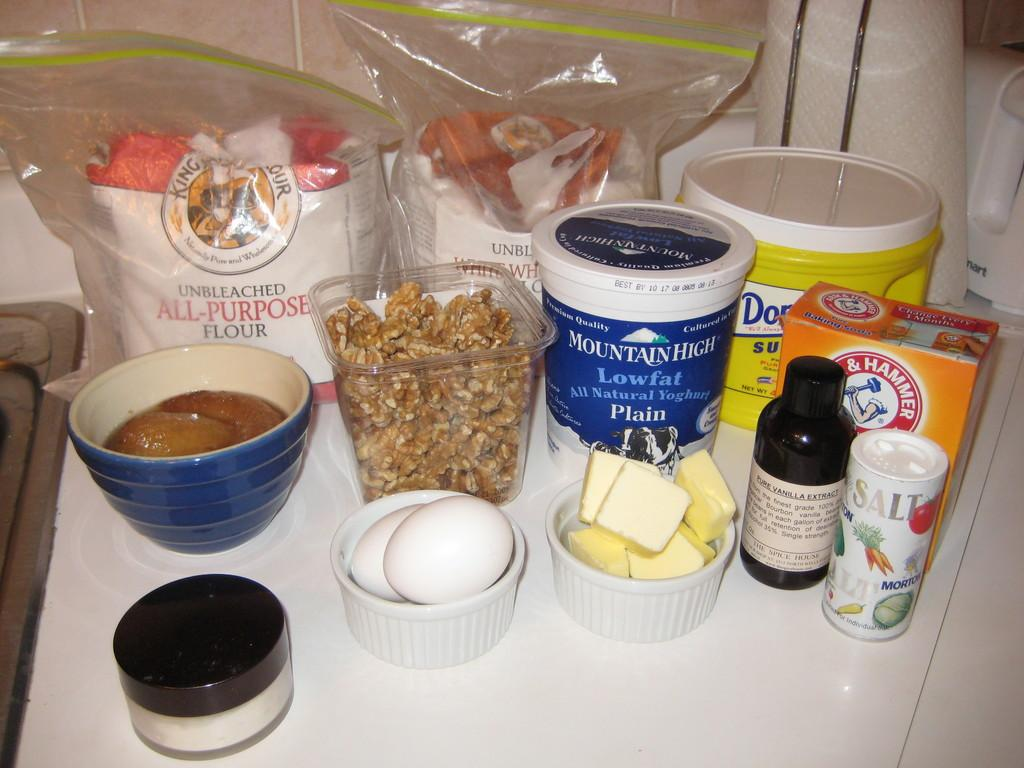<image>
Give a short and clear explanation of the subsequent image. There's a blue and white plastic container labeled Mountain High Low fat All Natural Yoghurt Plain 